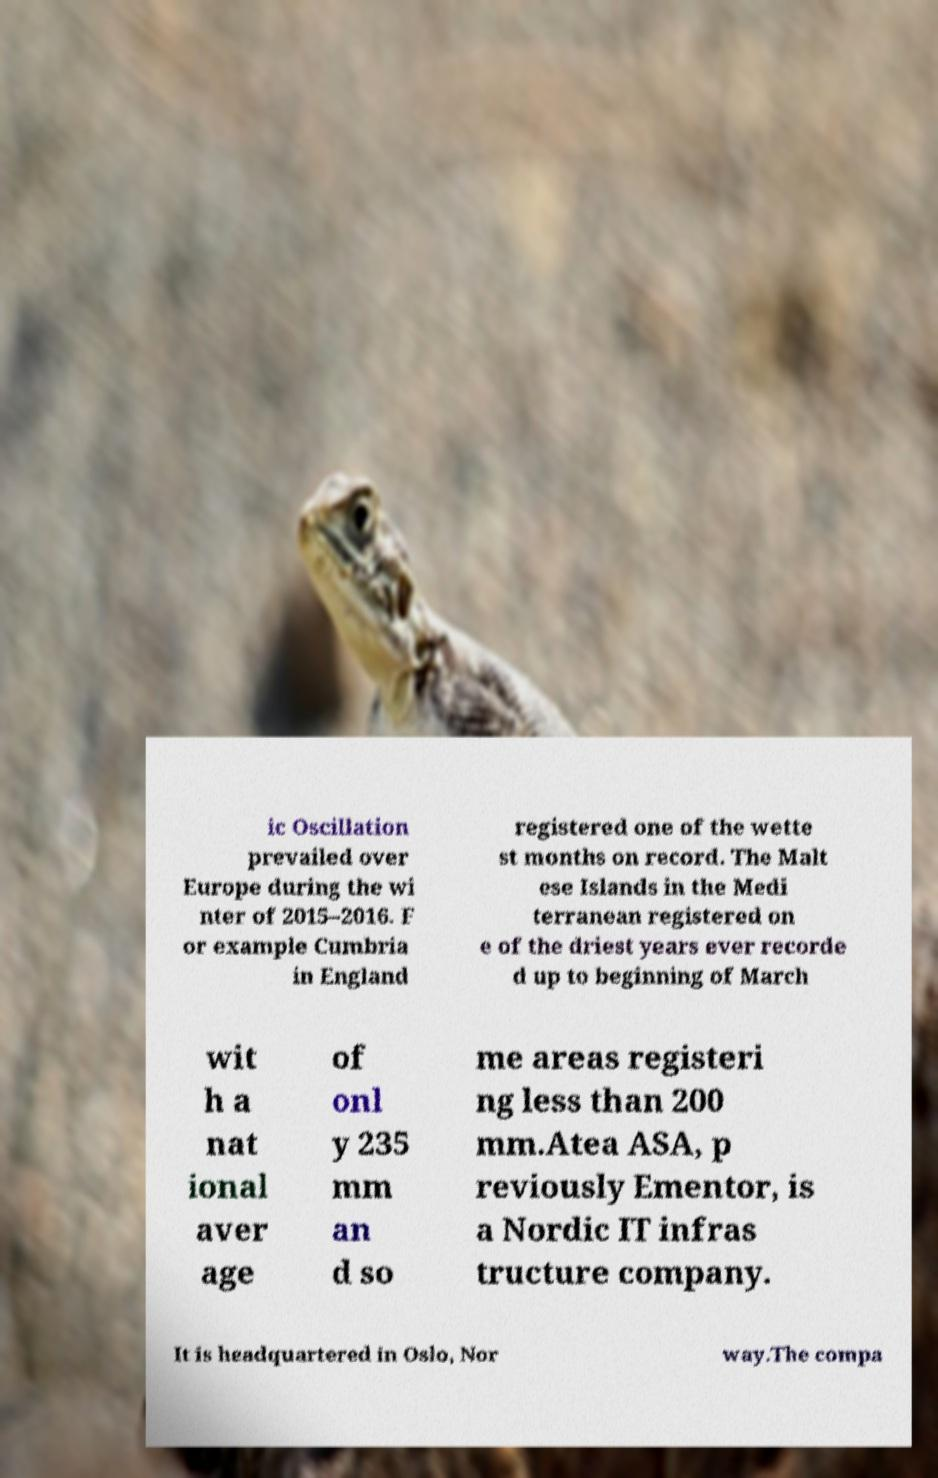Could you assist in decoding the text presented in this image and type it out clearly? ic Oscillation prevailed over Europe during the wi nter of 2015–2016. F or example Cumbria in England registered one of the wette st months on record. The Malt ese Islands in the Medi terranean registered on e of the driest years ever recorde d up to beginning of March wit h a nat ional aver age of onl y 235 mm an d so me areas registeri ng less than 200 mm.Atea ASA, p reviously Ementor, is a Nordic IT infras tructure company. It is headquartered in Oslo, Nor way.The compa 